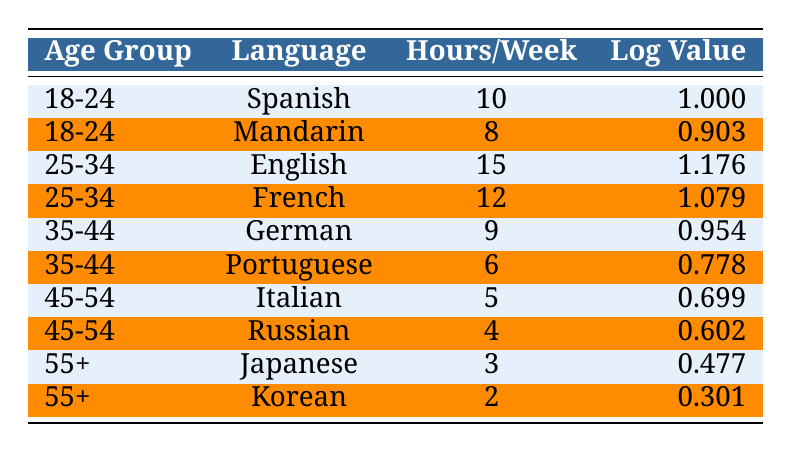What is the language preference for the age group 18-24? The table indicates that there are two language preferences for the age group 18-24: Spanish and Mandarin.
Answer: Spanish and Mandarin Which age group has the highest hours per week for reading? By scanning through the hours per week column, the age group 25-34 has the highest reading hours, specifically with English at 15 hours.
Answer: 25-34 What is the log value for reading hours in Italian for the age group 45-54? The log value for Italian, which is the language preference for the age group 45-54, is found directly in the table as 0.699.
Answer: 0.699 Is it true that the language preference with the highest log value is English? By examining the log values in the table, the highest log value is actually 1.176, which corresponds to English, confirming that the statement is true.
Answer: Yes What is the average hours per week for all age groups combined? To find the average, sum the hours (10 + 8 + 15 + 12 + 9 + 6 + 5 + 4 + 3 + 2 = 74) and divide by the total number of entries (10). So, 74 / 10 = 7.4 hours per week is the average.
Answer: 7.4 Which language preference from the age group 35-44 has a lower log value, German or Portuguese? The log values for German and Portuguese are compared and found to be 0.954 and 0.778, respectively. Therefore, Portuguese has the lower log value.
Answer: Portuguese What is the total number of hours per week for the age group 55+? By adding up the hours for the age group 55+ (3 hours for Japanese and 2 hours for Korean), the total is 5 hours per week.
Answer: 5 Which age group has the least number of hours read per week? Reviewing the hours per week for each age group, the age group 55+ has the least with 3 hours for Japanese and 2 hours for Korean.
Answer: 55+ 